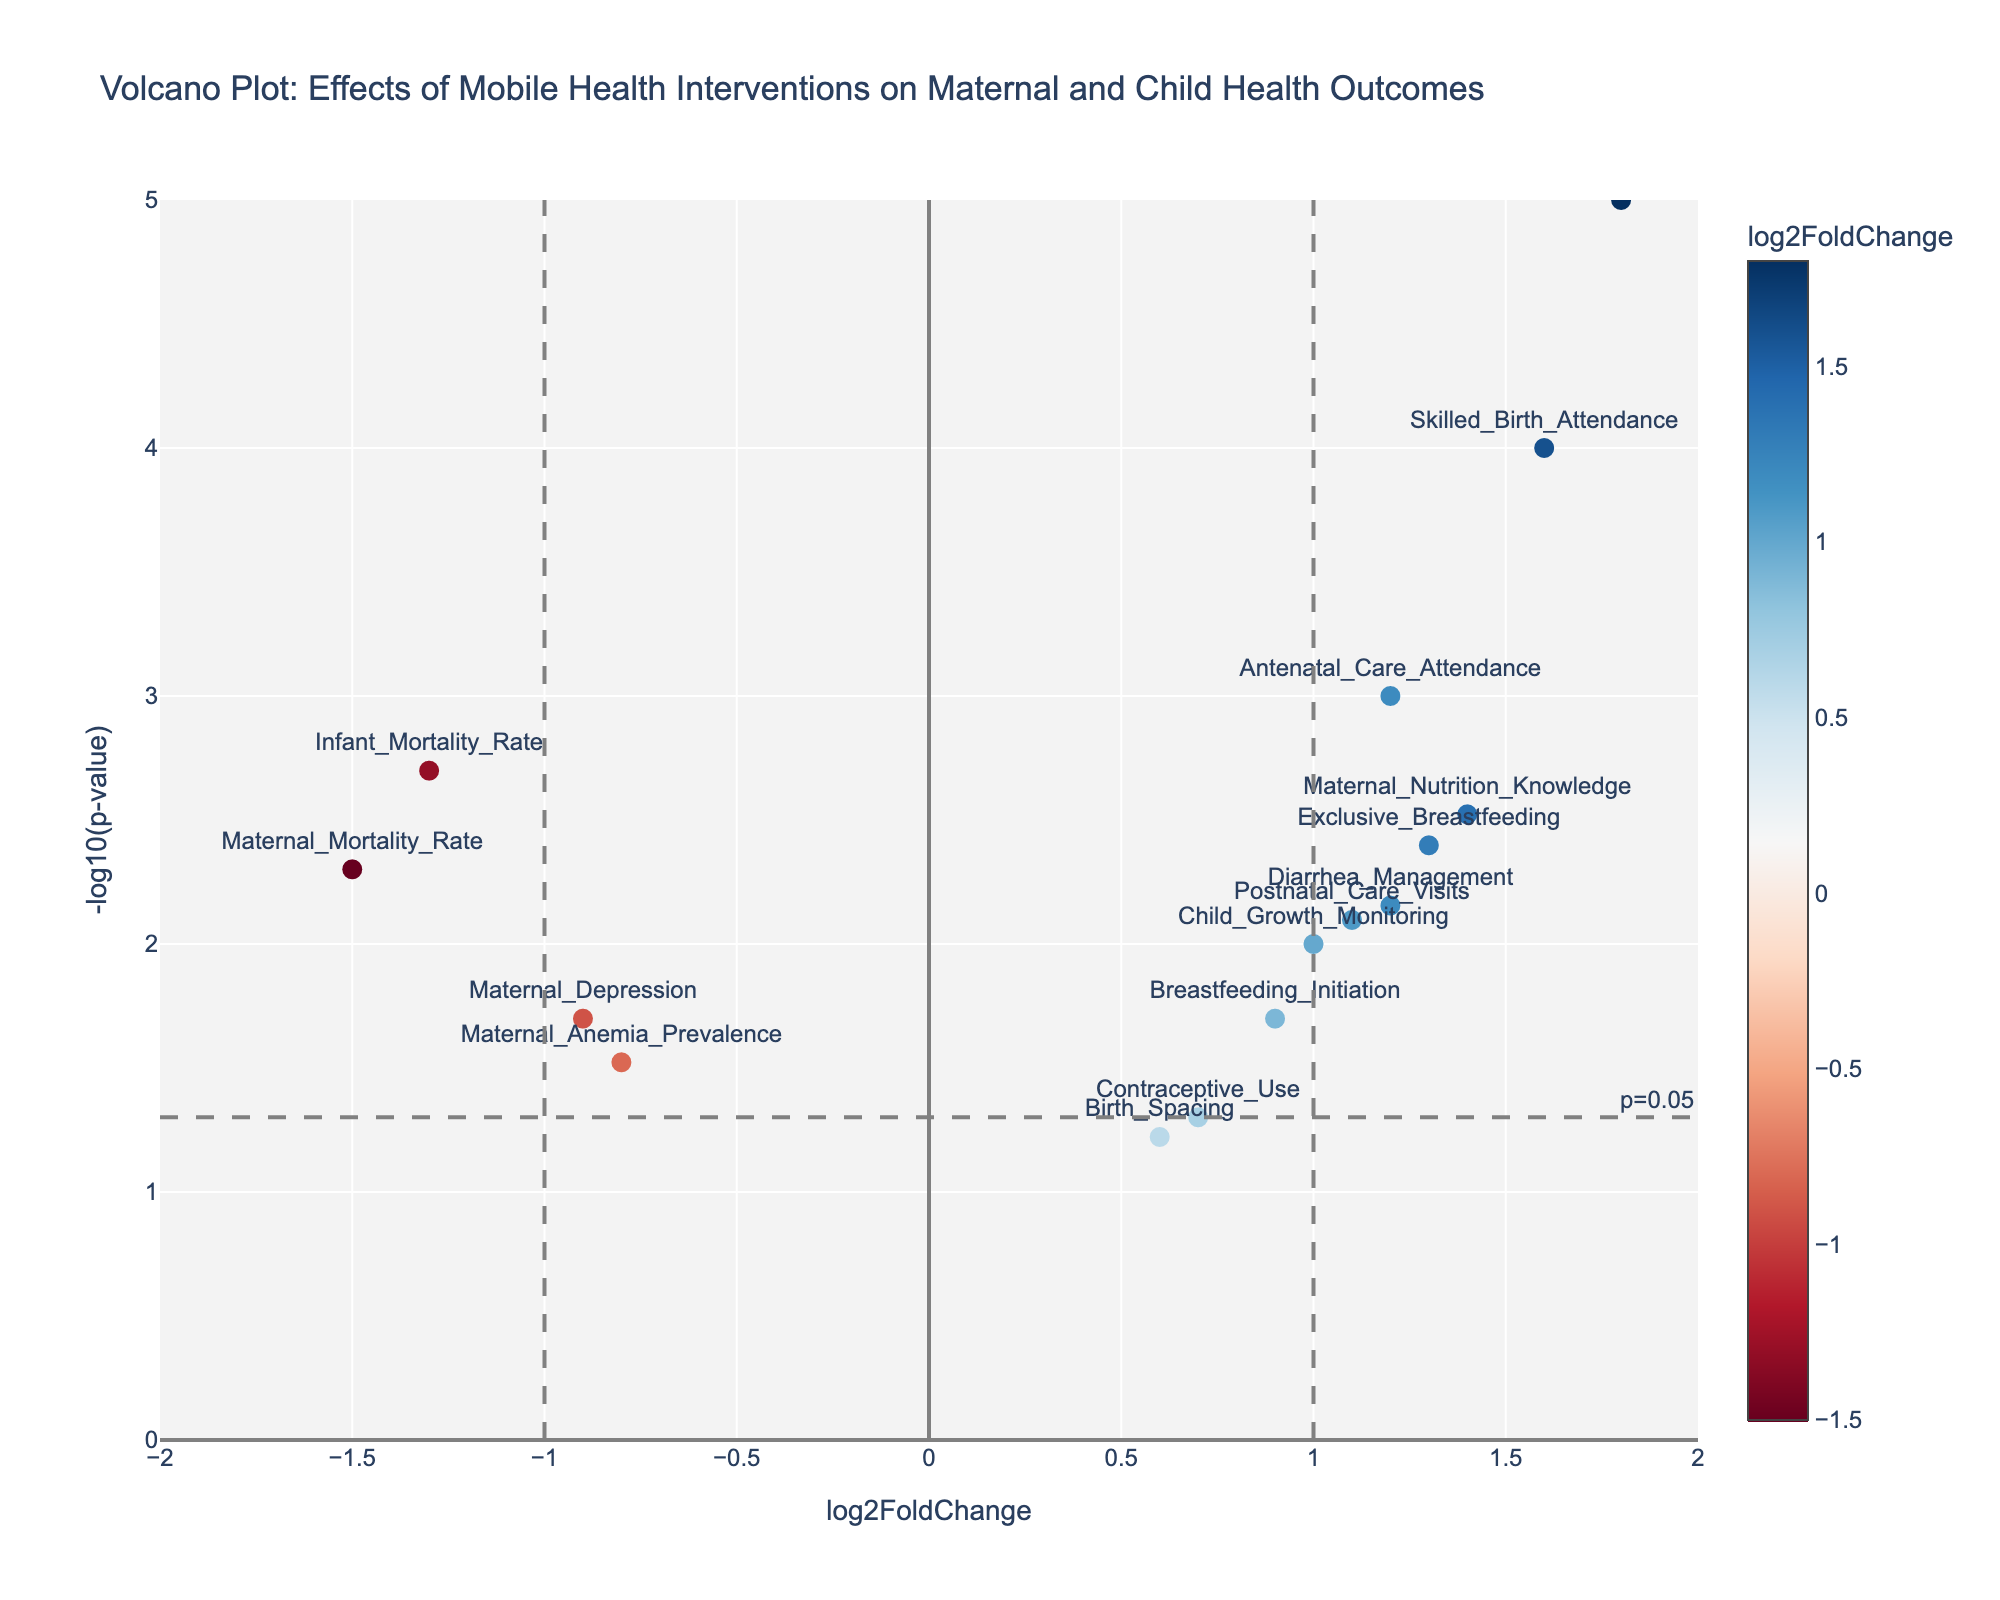What's the title of the plot? The title of a plot is typically located at the top of the figure. By looking at the figure, we can identify the title. The title reads, "Volcano Plot: Effects of Mobile Health Interventions on Maternal and Child Health Outcomes".
Answer: "Volcano Plot: Effects of Mobile Health Interventions on Maternal and Child Health Outcomes" What do the x-axis and y-axis represent? The x-axis and y-axis of a Volcano Plot usually represent different metrics. In this plot, the x-axis is labeled 'log2FoldChange' and the y-axis is '-log10(p-value)'.
Answer: x-axis: 'log2FoldChange', y-axis: '-log10(p-value)' Which outcome has the highest log2FoldChange? To determine which outcome has the highest log2FoldChange, we look for the data point that is farthest to the right. Here, 'Child_Immunization_Rates' is the farthest right with a log2FoldChange of 1.8.
Answer: Child_Immunization_Rates Which outcome has the lowest p-value? The lowest p-value corresponds to the highest value of -log10(p-value) on the y-axis. The data point with the highest y-value is 'Child_Immunization_Rates'.
Answer: Child_Immunization_Rates How many outcomes have a log2FoldChange greater than 1? We count the number of data points that are positioned to the right of the vertical line at log2FoldChange = 1. There are four outcomes that meet this criterion: 'Child_Immunization_Rates', 'Skilled_Birth_Attendance', 'Maternal_Nutrition_Knowledge', and 'Exclusive_Breastfeeding'.
Answer: 4 Which outcomes have a log2FoldChange less than -1? We observe the data points that are positioned to the left of the vertical line at log2FoldChange = -1. The outcomes 'Maternal_Mortality_Rate' and 'Infant_Mortality_Rate' meet this criterion.
Answer: Maternal_Mortality_Rate, Infant_Mortality_Rate What is the -log10(p-value) for 'Postnatal_Care_Visits'? We find the data point labeled 'Postnatal_Care_Visits' and observe its y-coordinate. The -log10(p-value) for 'Postnatal_Care_Visits' is approximately 2.1.
Answer: 2.1 Which outcome shows a noticeable decrease (log2FoldChange < 0) and is statistically significant (p-value < 0.05)? For an outcome to be considered, it needs to be below the horizontal significance line (-log10(p-value) > 1.3) and have a log2FoldChange less than 0. The outcomes 'Maternal_Mortality_Rate', 'Infant_Mortality_Rate', and 'Maternal_Depression' meet these criteria but 'Maternal_Mortality_Rate' and 'Infant_Mortality_Rate' have more significant negative log2FoldChanges.
Answer: Maternal_Mortality_Rate, Infant_Mortality_Rate Which outcomes are not statistically significant (p-value > 0.05)? The significance threshold is p-value = 0.05, corresponding to -log10(p-value) = 1.3. Outcomes with a -log10(p-value) less than 1.3 are 'Contraceptive_Use' and 'Birth_Spacing'.
Answer: Contraceptive_Use, Birth_Spacing 